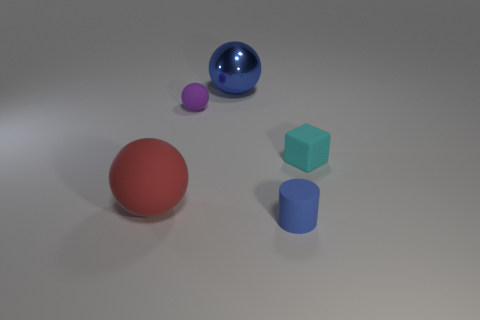Are the blue thing in front of the metallic sphere and the large ball that is behind the large red ball made of the same material?
Make the answer very short. No. There is a tiny thing that is to the right of the tiny rubber object in front of the small cyan rubber cube; what is it made of?
Offer a terse response. Rubber. There is a small object right of the tiny matte cylinder; what is it made of?
Give a very brief answer. Rubber. What number of other cyan matte things are the same shape as the cyan object?
Offer a terse response. 0. Is the color of the large metallic thing the same as the tiny rubber cylinder?
Give a very brief answer. Yes. There is a large thing behind the tiny cyan object right of the big sphere to the left of the blue metal sphere; what is it made of?
Keep it short and to the point. Metal. There is a tiny cyan rubber thing; are there any red matte spheres in front of it?
Make the answer very short. Yes. What is the shape of the purple object that is the same size as the block?
Ensure brevity in your answer.  Sphere. Do the cube and the tiny blue object have the same material?
Your response must be concise. Yes. How many matte things are either big things or purple spheres?
Offer a very short reply. 2. 